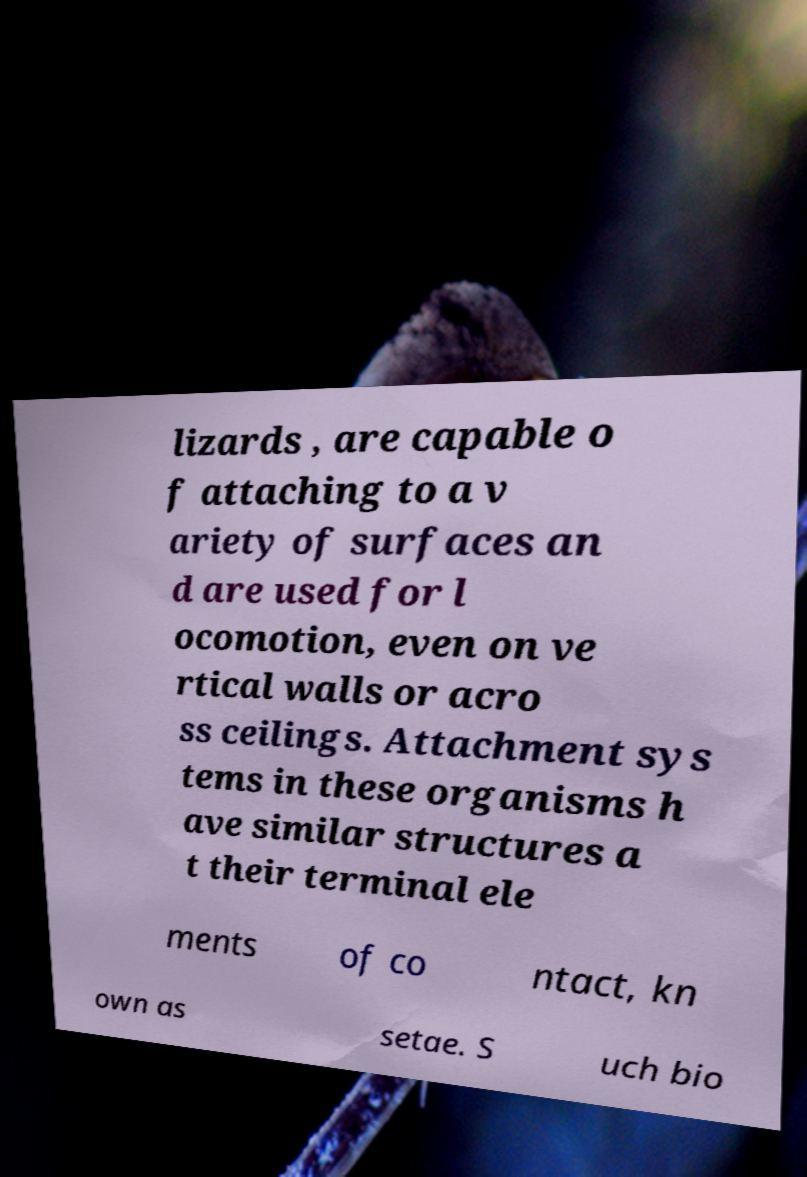There's text embedded in this image that I need extracted. Can you transcribe it verbatim? lizards , are capable o f attaching to a v ariety of surfaces an d are used for l ocomotion, even on ve rtical walls or acro ss ceilings. Attachment sys tems in these organisms h ave similar structures a t their terminal ele ments of co ntact, kn own as setae. S uch bio 